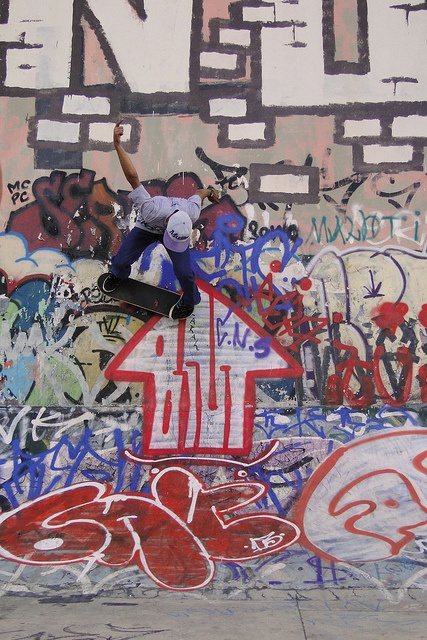Describe the objects in this image and their specific colors. I can see people in black, darkgray, navy, and gray tones and skateboard in black, gray, and maroon tones in this image. 